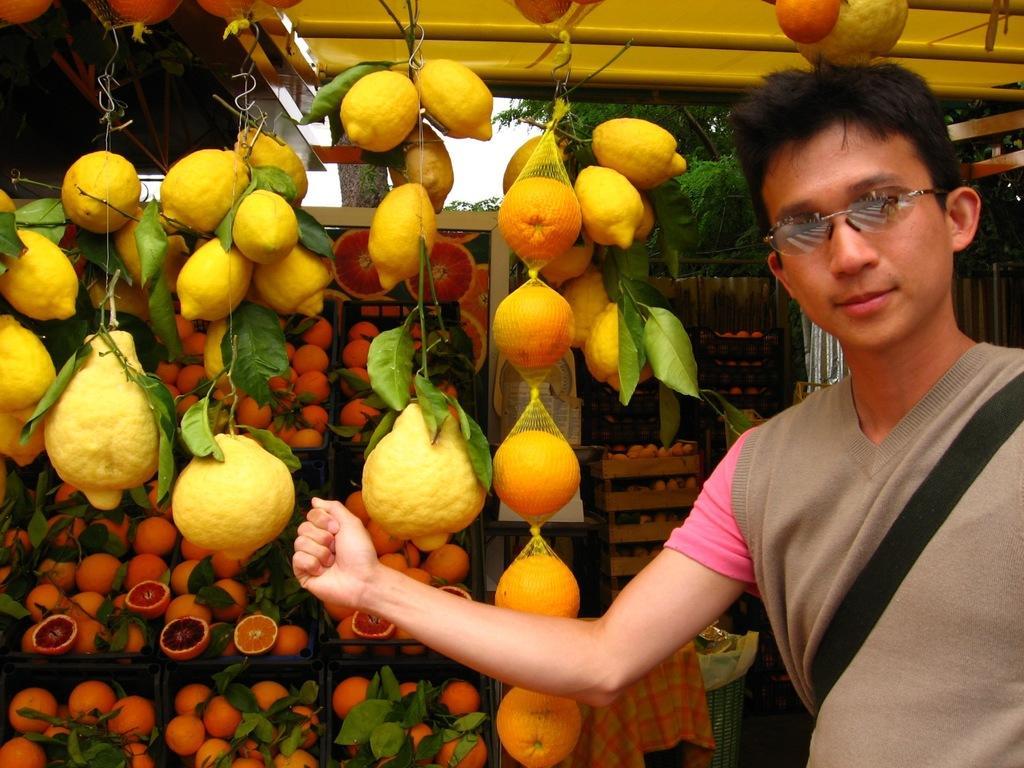Can you describe this image briefly? On the right side, there is a person in gray color jacket, wearing a bag, smiling and standing. On the left side, there are fruits hanged and there are fruits arranged on the shelves. In the background, there are trees, there is sky and there are other objects. 